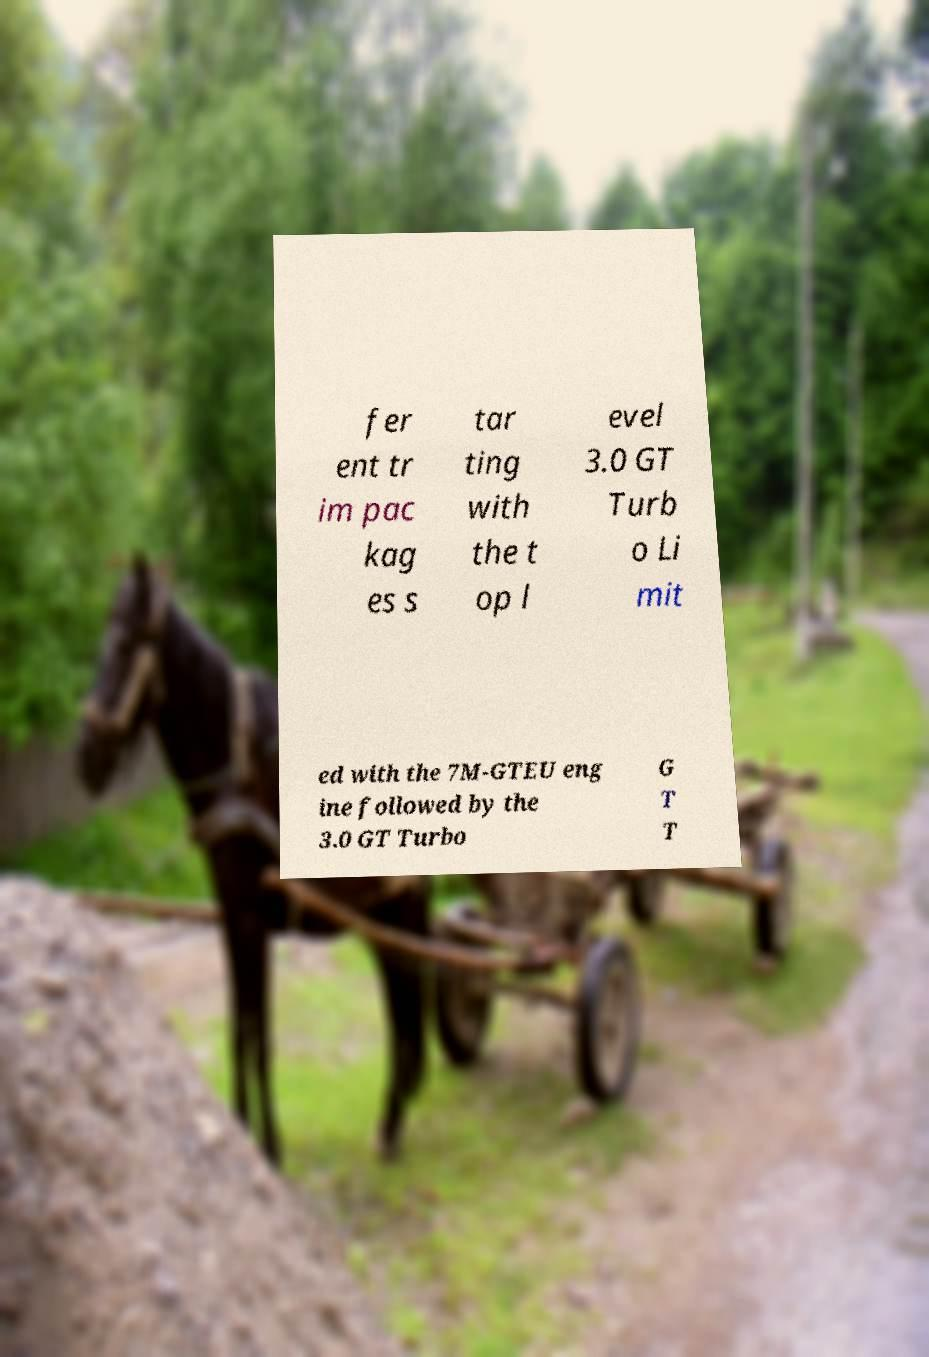For documentation purposes, I need the text within this image transcribed. Could you provide that? fer ent tr im pac kag es s tar ting with the t op l evel 3.0 GT Turb o Li mit ed with the 7M-GTEU eng ine followed by the 3.0 GT Turbo G T T 